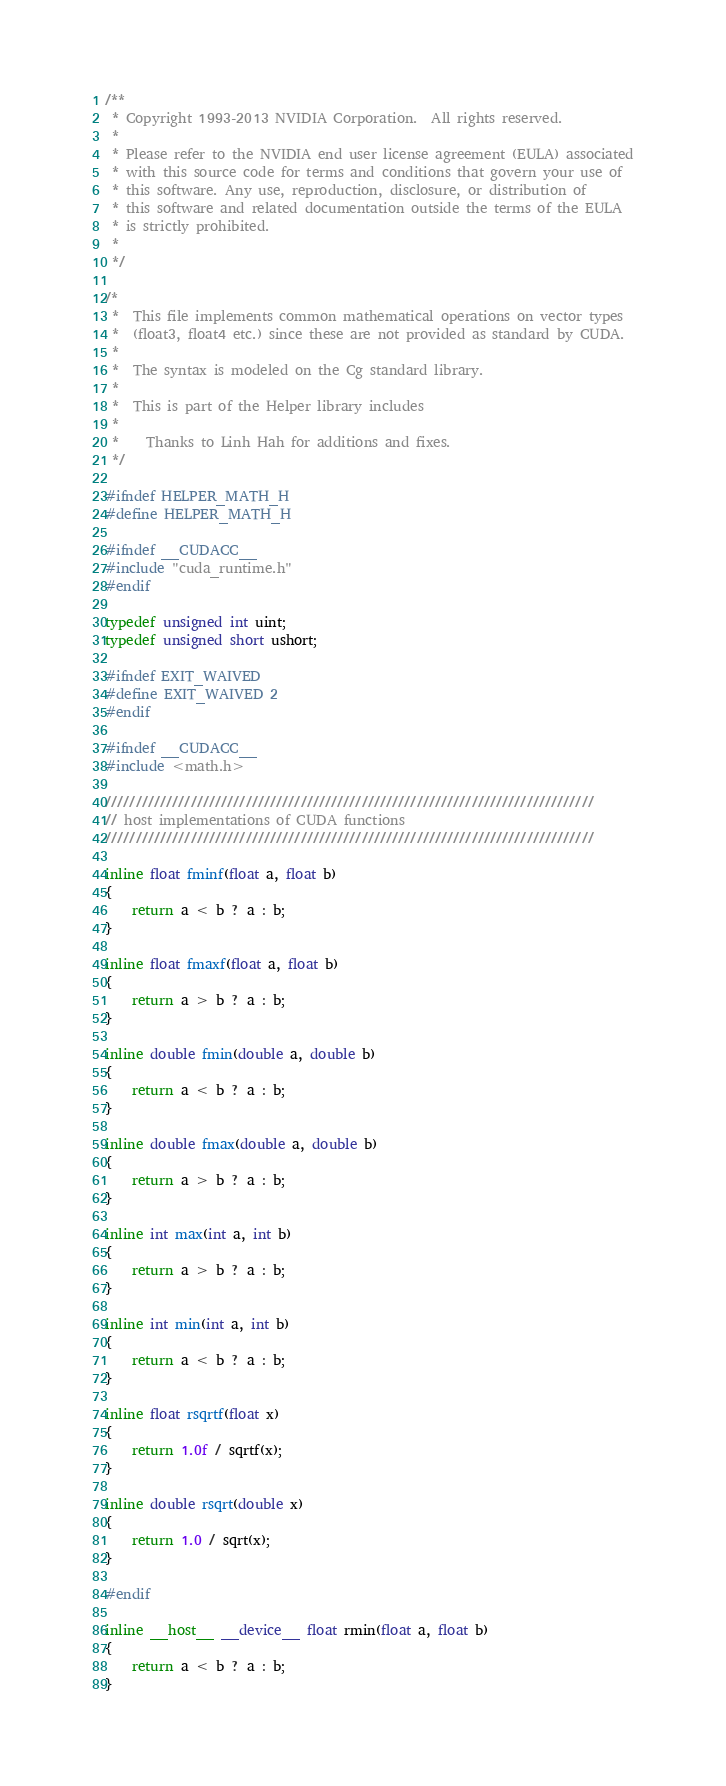Convert code to text. <code><loc_0><loc_0><loc_500><loc_500><_Cuda_>/**
 * Copyright 1993-2013 NVIDIA Corporation.  All rights reserved.
 *
 * Please refer to the NVIDIA end user license agreement (EULA) associated
 * with this source code for terms and conditions that govern your use of
 * this software. Any use, reproduction, disclosure, or distribution of
 * this software and related documentation outside the terms of the EULA
 * is strictly prohibited.
 *
 */

/*
 *  This file implements common mathematical operations on vector types
 *  (float3, float4 etc.) since these are not provided as standard by CUDA.
 *
 *  The syntax is modeled on the Cg standard library.
 *
 *  This is part of the Helper library includes
 *
 *    Thanks to Linh Hah for additions and fixes.
 */

#ifndef HELPER_MATH_H
#define HELPER_MATH_H

#ifndef __CUDACC__
#include "cuda_runtime.h"
#endif

typedef unsigned int uint;
typedef unsigned short ushort;

#ifndef EXIT_WAIVED
#define EXIT_WAIVED 2
#endif

#ifndef __CUDACC__
#include <math.h>

////////////////////////////////////////////////////////////////////////////////
// host implementations of CUDA functions
////////////////////////////////////////////////////////////////////////////////

inline float fminf(float a, float b)
{
    return a < b ? a : b;
}

inline float fmaxf(float a, float b)
{
    return a > b ? a : b;
}

inline double fmin(double a, double b)
{
    return a < b ? a : b;
}

inline double fmax(double a, double b)
{
    return a > b ? a : b;
}

inline int max(int a, int b)
{
    return a > b ? a : b;
}

inline int min(int a, int b)
{
    return a < b ? a : b;
}

inline float rsqrtf(float x)
{
    return 1.0f / sqrtf(x);
}

inline double rsqrt(double x)
{
	return 1.0 / sqrt(x);
}

#endif

inline __host__ __device__ float rmin(float a, float b)
{
    return a < b ? a : b;
}
</code> 